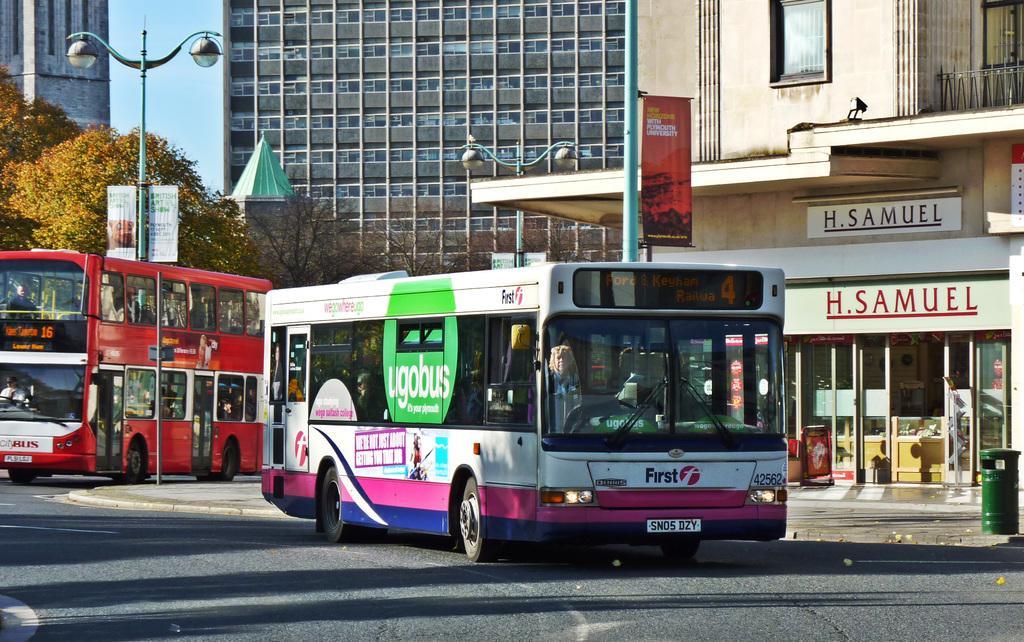Describe this image in one or two sentences. In this picture we can see buildings with windows and in front of the buildings we have trees, pole, light, buses on the road and we have banner ticket to the pole and here it is a bin on foot path. 